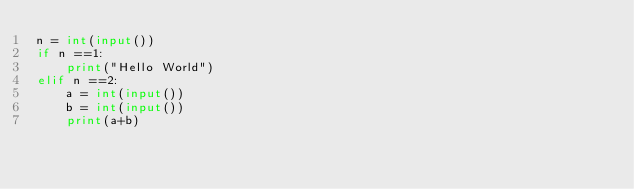Convert code to text. <code><loc_0><loc_0><loc_500><loc_500><_Python_>n = int(input())
if n ==1:
    print("Hello World")
elif n ==2:
    a = int(input())
    b = int(input())
    print(a+b)</code> 